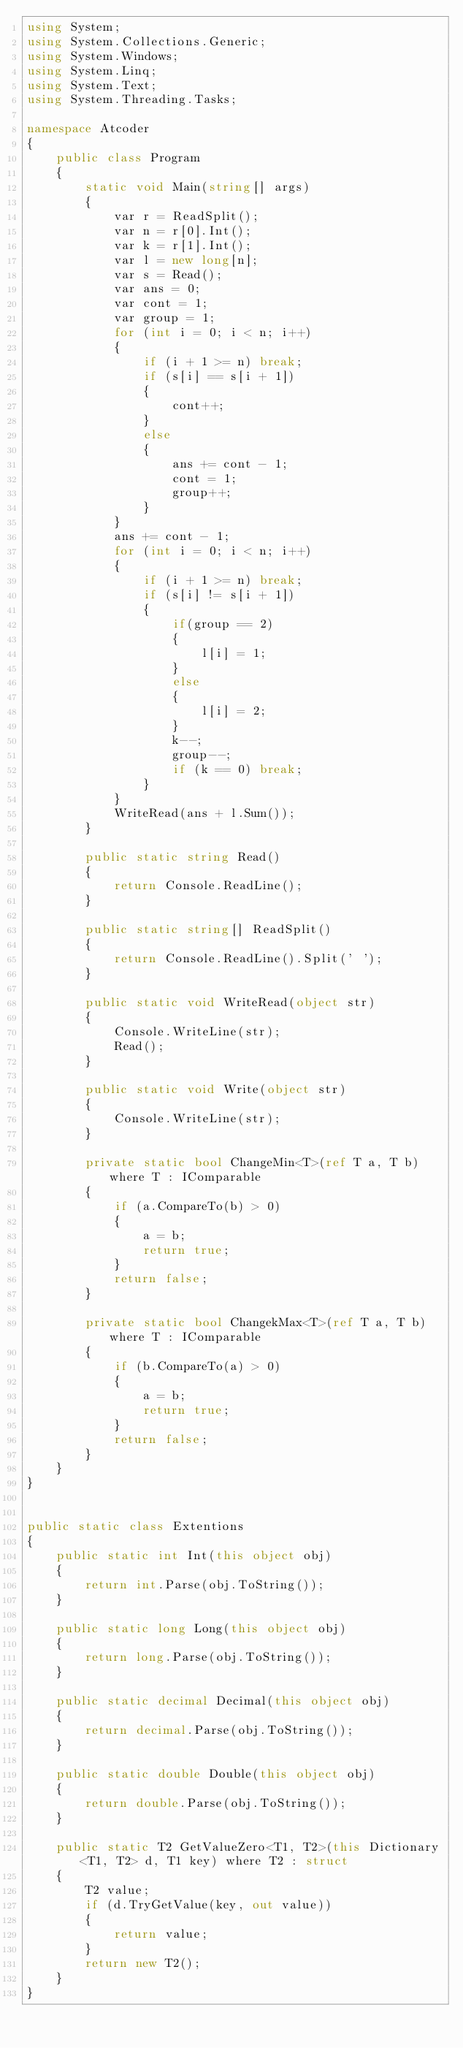Convert code to text. <code><loc_0><loc_0><loc_500><loc_500><_C#_>using System;
using System.Collections.Generic;
using System.Windows;
using System.Linq;
using System.Text;
using System.Threading.Tasks;

namespace Atcoder
{
    public class Program
    {
        static void Main(string[] args)
        {
            var r = ReadSplit();
            var n = r[0].Int();
            var k = r[1].Int();
            var l = new long[n];
            var s = Read();
            var ans = 0;
            var cont = 1;
            var group = 1;
            for (int i = 0; i < n; i++)
            {
                if (i + 1 >= n) break;
                if (s[i] == s[i + 1])
                {
                    cont++;
                }
                else
                {
                    ans += cont - 1;
                    cont = 1;
                    group++;
                }
            }
            ans += cont - 1;
            for (int i = 0; i < n; i++)
            {
                if (i + 1 >= n) break;
                if (s[i] != s[i + 1])
                {
                    if(group == 2)
                    {
                        l[i] = 1;
                    }
                    else
                    {
                        l[i] = 2;
                    }
                    k--;
                    group--;
                    if (k == 0) break;
                }
            }
            WriteRead(ans + l.Sum());
        }

        public static string Read()
        {
            return Console.ReadLine();
        }

        public static string[] ReadSplit()
        {
            return Console.ReadLine().Split(' ');
        }

        public static void WriteRead(object str)
        {
            Console.WriteLine(str);
            Read();
        }

        public static void Write(object str)
        {
            Console.WriteLine(str);
        }

        private static bool ChangeMin<T>(ref T a, T b) where T : IComparable
        {
            if (a.CompareTo(b) > 0)
            {
                a = b;
                return true;
            }
            return false;
        }

        private static bool ChangekMax<T>(ref T a, T b) where T : IComparable
        {
            if (b.CompareTo(a) > 0)
            {
                a = b;
                return true;
            }
            return false;
        }
    }
}


public static class Extentions
{
    public static int Int(this object obj)
    {
        return int.Parse(obj.ToString());
    }

    public static long Long(this object obj)
    {
        return long.Parse(obj.ToString());
    }

    public static decimal Decimal(this object obj)
    {
        return decimal.Parse(obj.ToString());
    }

    public static double Double(this object obj)
    {
        return double.Parse(obj.ToString());
    }

    public static T2 GetValueZero<T1, T2>(this Dictionary<T1, T2> d, T1 key) where T2 : struct
    {
        T2 value;
        if (d.TryGetValue(key, out value))
        {
            return value;
        }
        return new T2();
    }
}

</code> 